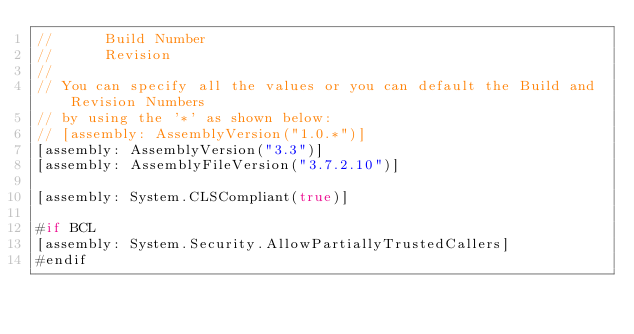Convert code to text. <code><loc_0><loc_0><loc_500><loc_500><_C#_>//      Build Number
//      Revision
//
// You can specify all the values or you can default the Build and Revision Numbers 
// by using the '*' as shown below:
// [assembly: AssemblyVersion("1.0.*")]
[assembly: AssemblyVersion("3.3")]
[assembly: AssemblyFileVersion("3.7.2.10")]

[assembly: System.CLSCompliant(true)]

#if BCL
[assembly: System.Security.AllowPartiallyTrustedCallers]
#endif</code> 